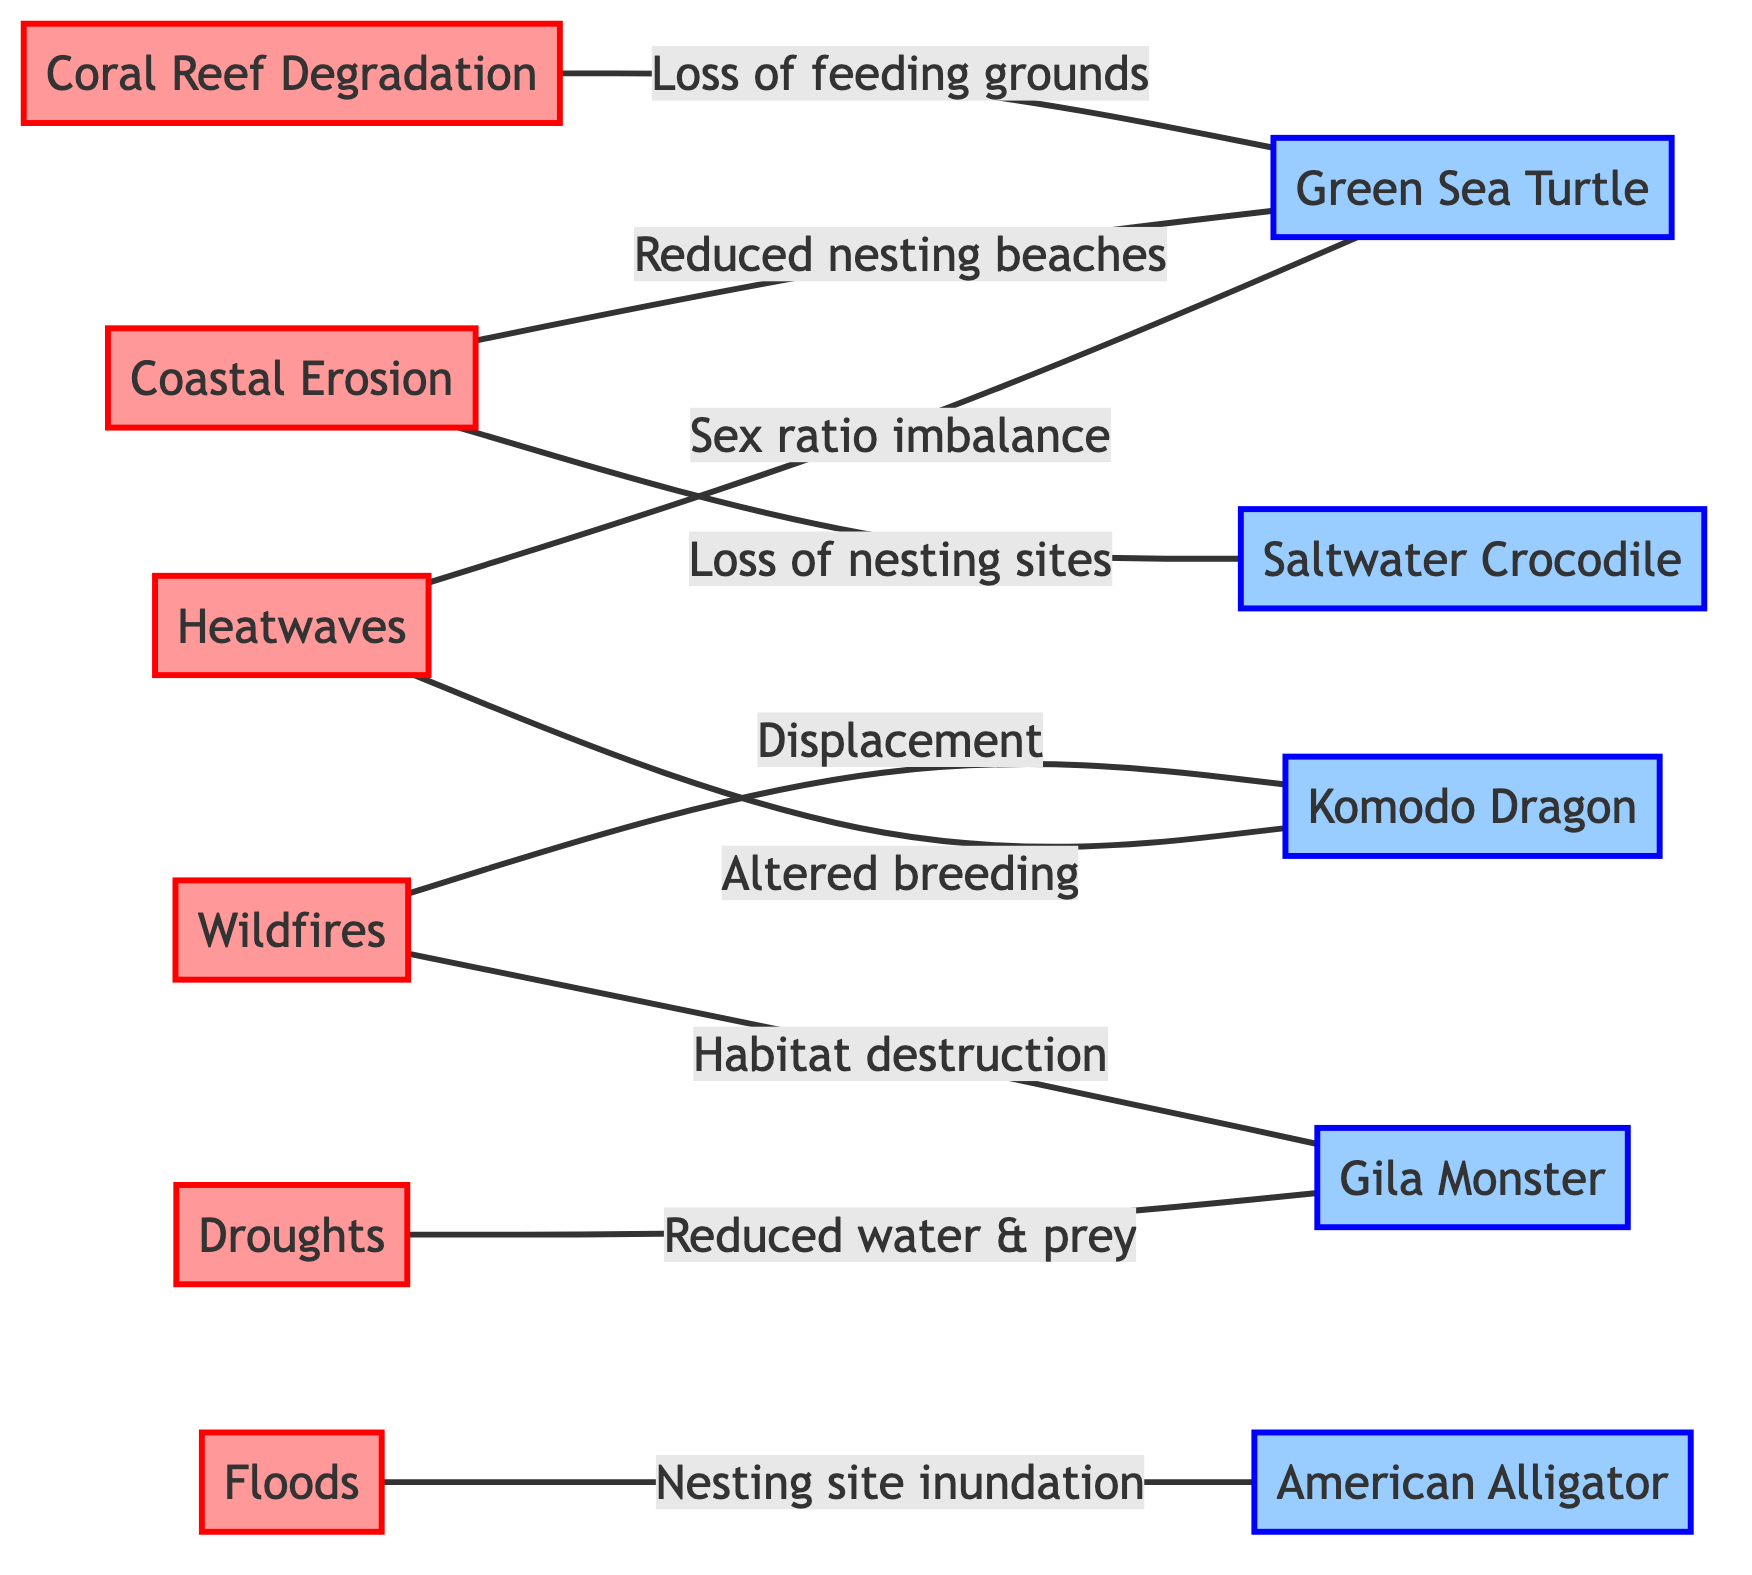What climate event affects the Green Sea Turtle? According to the diagram, the Green Sea Turtle is connected to three climate events: Heatwaves, Coastal Erosion, and Coral Reef Degradation. Each of these events impacts the turtle in different ways, but all are explicitly linked in the diagram.
Answer: Heatwaves, Coastal Erosion, Coral Reef Degradation How many edges connect Droughts to reptile species? There is one edge connecting Droughts to the Gila Monster in the diagram. This edge describes the impact of drought on the availability of drinking water and prey for the Gila Monster.
Answer: 1 Which reptile species is affected by coastal erosion? The diagram shows that Coastal Erosion is connected to two reptile species: the Saltwater Crocodile and the Green Sea Turtle.
Answer: Saltwater Crocodile, Green Sea Turtle What is the impact of wildfires on the Komodo Dragon? The edge connecting Wildfires to the Komodo Dragon specifies that it leads to habitat destruction, which causes displacement and reduced prey availability for the Komodo Dragon.
Answer: Habitat destruction leading to displacement and reduced prey How many total nodes are displayed in the diagram? The diagram contains a total of 15 nodes: 6 climate events and 5 reptile species, leading to 11 distinct events and species combined.
Answer: 15 Which reptile species experience nesting site issues from floods? The American Alligator is directly connected to Floods in the diagram, indicating that floods inundate its nesting sites, affecting hatchling survival.
Answer: American Alligator Which climate events directly affect the Gila Monster? The Gila Monster is affected by two climate events according to the diagram: Droughts and Wildfires. The Droughts limit water and prey, while Wildfires destroy habitat and food resources.
Answer: Droughts, Wildfires Is there a climate event that affects more than two reptile species? Analyzing the edges, none of the climate events are linked to more than two reptile species. Each event has specific impacts on at most two species, maintaining a clear one-to-many relationship.
Answer: No What is the relationship between Heatwaves and Gila Monster? The diagram connects Heatwaves to the Gila Monster, where the description indicates that Heatwaves reduce available drinking water and prey for the species.
Answer: Reduces available drinking water and prey 